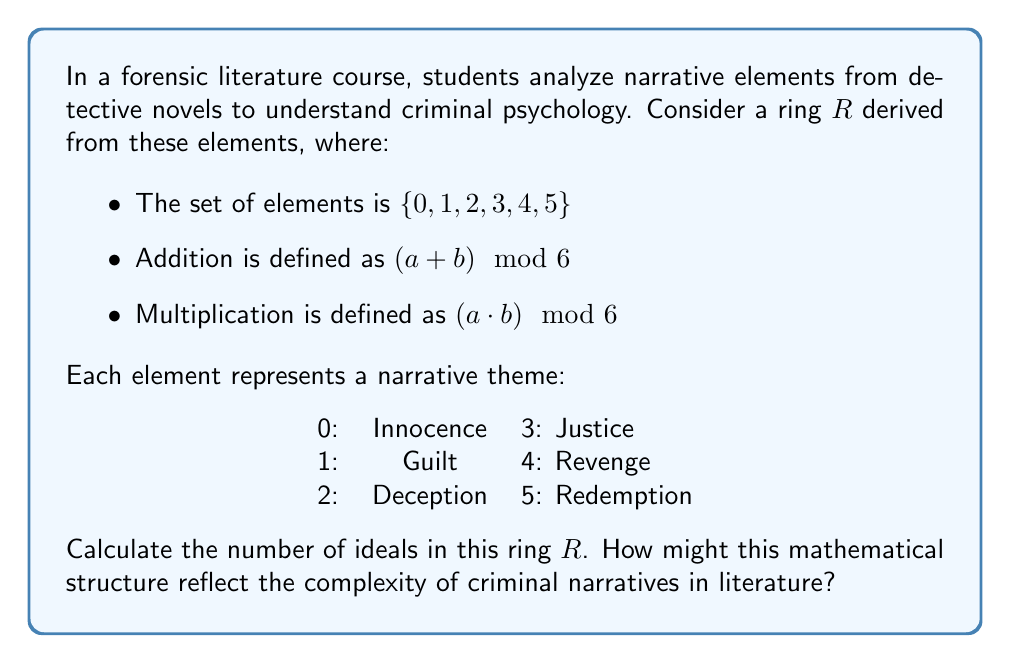Provide a solution to this math problem. To find the number of ideals in the ring $R$, we'll follow these steps:

1) First, let's identify the properties of $R$:
   - $R$ is a commutative ring with unity (1).
   - $R$ is isomorphic to $\mathbb{Z}_6$, the ring of integers modulo 6.

2) In $\mathbb{Z}_6$, the ideals are precisely the subgroups of the additive group.

3) The subgroups of $\mathbb{Z}_6$ are determined by its divisors. The divisors of 6 are 1, 2, 3, and 6.

4) Let's list out the ideals:
   - $\langle 0 \rangle = \{0\}$ (the zero ideal)
   - $\langle 1 \rangle = \{0, 1, 2, 3, 4, 5\}$ (the entire ring)
   - $\langle 2 \rangle = \{0, 2, 4\}$
   - $\langle 3 \rangle = \{0, 3\}$

5) Therefore, there are 4 ideals in total.

Interpretation for literature:
This mathematical structure reflects the complexity of criminal narratives by showing how themes interrelate. The ideals represent coherent substructures within the narrative:

- $\{0\}$: The notion of pure innocence, isolated from other themes.
- $\{0, 1, 2, 3, 4, 5\}$: The full complexity of intertwined themes in a rich narrative.
- $\{0, 2, 4\}$: A narrative focusing on the cycle of innocence, deception, and revenge.
- $\{0, 3\}$: A story centered on the duality of innocence and justice.

The limited number of ideals suggests that while criminal narratives can be complex, they often fall into recognizable patterns or structures, much like how literary genres have common thematic elements.
Answer: 4 ideals 